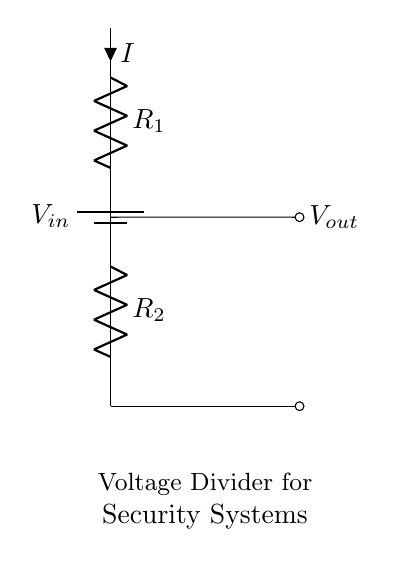What is the input voltage labeled in the circuit? The input voltage is labeled as V in the diagram. The label indicates the source of power for the circuit.
Answer: V in What are the two resistors in the voltage divider? The resistors in the voltage divider are labeled as R1 and R2 in the diagram. These resistors are used to divide the input voltage into a lower output voltage.
Answer: R1 and R2 What is the output voltage output in the circuit? The output voltage is labeled as V out, which indicates the voltage level after it has been divided by the resistors R1 and R2.
Answer: V out How does current flow in this circuit? Current flows from the battery through R1 and R2, creating a path for the current to travel. The current direction is indicated by the arrows next to R1.
Answer: From battery through R1 and R2 What role does the voltage divider play in security systems? The voltage divider adjusts voltage levels, which can help in providing compatible voltage to different components in a security system. This ensures proper operation of sensors and other devices.
Answer: Adjusts voltage levels for components What is the formula for calculating the output voltage in a voltage divider? The output voltage can be calculated using the formula V out = V in * (R2 / (R1 + R2)), where V in is the input voltage, and R1 and R2 are the resistances of the two resistors. This shows the relationship between input and output voltage depending on the resistor values.
Answer: V out = V in * (R2 / (R1 + R2)) What happens if R2 has a very low resistance compared to R1? If R2 has a very low resistance compared to R1, the output voltage V out will approach zero volts because most of the voltage will appear across R1, resulting in minimal voltage drop across R2.
Answer: V out approaches zero volts 